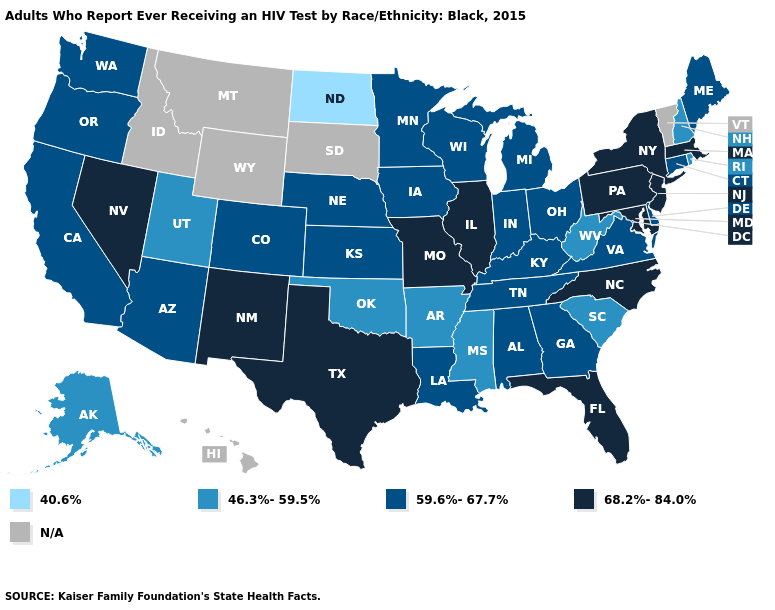What is the value of Tennessee?
Write a very short answer. 59.6%-67.7%. Name the states that have a value in the range 59.6%-67.7%?
Answer briefly. Alabama, Arizona, California, Colorado, Connecticut, Delaware, Georgia, Indiana, Iowa, Kansas, Kentucky, Louisiana, Maine, Michigan, Minnesota, Nebraska, Ohio, Oregon, Tennessee, Virginia, Washington, Wisconsin. What is the value of Rhode Island?
Write a very short answer. 46.3%-59.5%. Which states have the highest value in the USA?
Short answer required. Florida, Illinois, Maryland, Massachusetts, Missouri, Nevada, New Jersey, New Mexico, New York, North Carolina, Pennsylvania, Texas. How many symbols are there in the legend?
Short answer required. 5. What is the value of New Jersey?
Short answer required. 68.2%-84.0%. What is the value of Minnesota?
Concise answer only. 59.6%-67.7%. Does Georgia have the highest value in the USA?
Short answer required. No. What is the value of Iowa?
Concise answer only. 59.6%-67.7%. Does North Dakota have the lowest value in the USA?
Keep it brief. Yes. What is the lowest value in states that border Connecticut?
Be succinct. 46.3%-59.5%. Does New Hampshire have the lowest value in the Northeast?
Keep it brief. Yes. What is the value of Ohio?
Keep it brief. 59.6%-67.7%. 